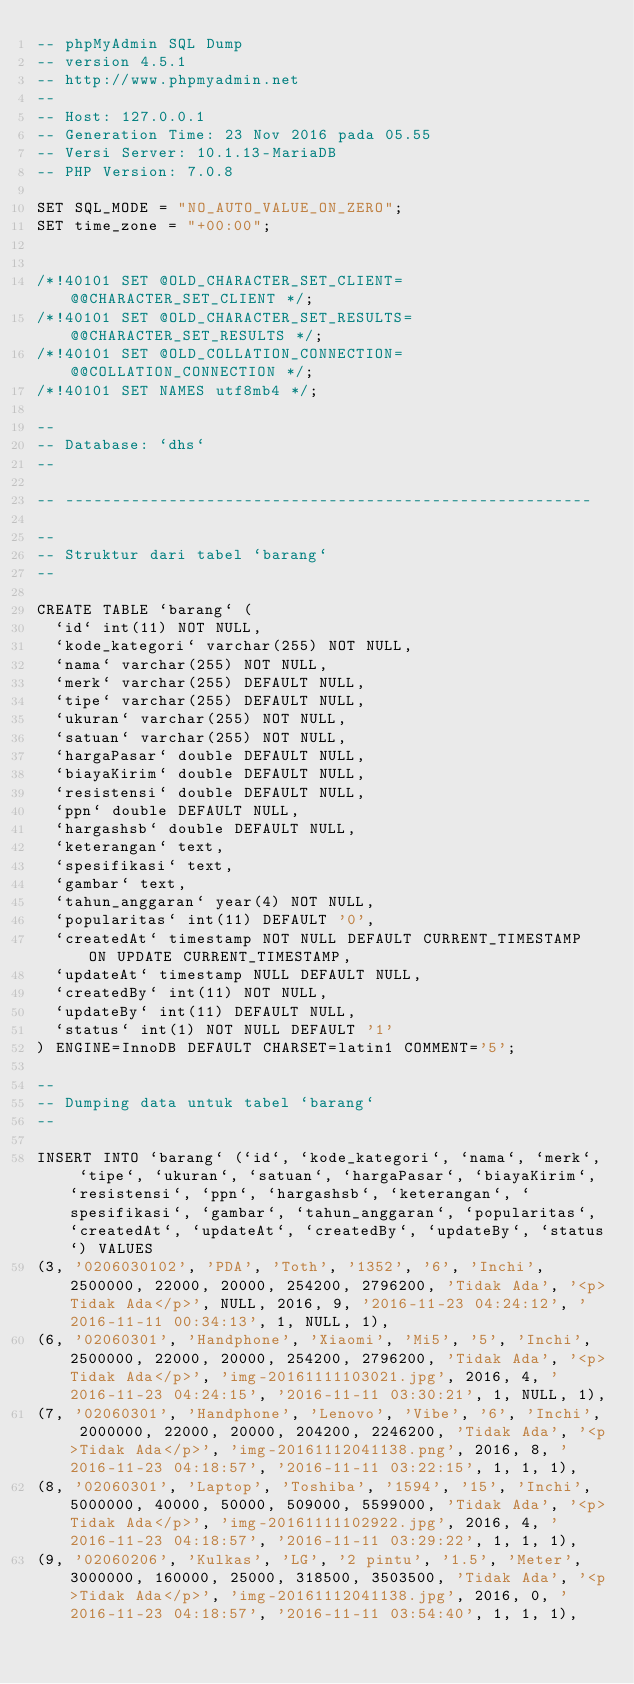<code> <loc_0><loc_0><loc_500><loc_500><_SQL_>-- phpMyAdmin SQL Dump
-- version 4.5.1
-- http://www.phpmyadmin.net
--
-- Host: 127.0.0.1
-- Generation Time: 23 Nov 2016 pada 05.55
-- Versi Server: 10.1.13-MariaDB
-- PHP Version: 7.0.8

SET SQL_MODE = "NO_AUTO_VALUE_ON_ZERO";
SET time_zone = "+00:00";


/*!40101 SET @OLD_CHARACTER_SET_CLIENT=@@CHARACTER_SET_CLIENT */;
/*!40101 SET @OLD_CHARACTER_SET_RESULTS=@@CHARACTER_SET_RESULTS */;
/*!40101 SET @OLD_COLLATION_CONNECTION=@@COLLATION_CONNECTION */;
/*!40101 SET NAMES utf8mb4 */;

--
-- Database: `dhs`
--

-- --------------------------------------------------------

--
-- Struktur dari tabel `barang`
--

CREATE TABLE `barang` (
  `id` int(11) NOT NULL,
  `kode_kategori` varchar(255) NOT NULL,
  `nama` varchar(255) NOT NULL,
  `merk` varchar(255) DEFAULT NULL,
  `tipe` varchar(255) DEFAULT NULL,
  `ukuran` varchar(255) NOT NULL,
  `satuan` varchar(255) NOT NULL,
  `hargaPasar` double DEFAULT NULL,
  `biayaKirim` double DEFAULT NULL,
  `resistensi` double DEFAULT NULL,
  `ppn` double DEFAULT NULL,
  `hargashsb` double DEFAULT NULL,
  `keterangan` text,
  `spesifikasi` text,
  `gambar` text,
  `tahun_anggaran` year(4) NOT NULL,
  `popularitas` int(11) DEFAULT '0',
  `createdAt` timestamp NOT NULL DEFAULT CURRENT_TIMESTAMP ON UPDATE CURRENT_TIMESTAMP,
  `updateAt` timestamp NULL DEFAULT NULL,
  `createdBy` int(11) NOT NULL,
  `updateBy` int(11) DEFAULT NULL,
  `status` int(1) NOT NULL DEFAULT '1'
) ENGINE=InnoDB DEFAULT CHARSET=latin1 COMMENT='5';

--
-- Dumping data untuk tabel `barang`
--

INSERT INTO `barang` (`id`, `kode_kategori`, `nama`, `merk`, `tipe`, `ukuran`, `satuan`, `hargaPasar`, `biayaKirim`, `resistensi`, `ppn`, `hargashsb`, `keterangan`, `spesifikasi`, `gambar`, `tahun_anggaran`, `popularitas`, `createdAt`, `updateAt`, `createdBy`, `updateBy`, `status`) VALUES
(3, '0206030102', 'PDA', 'Toth', '1352', '6', 'Inchi', 2500000, 22000, 20000, 254200, 2796200, 'Tidak Ada', '<p>Tidak Ada</p>', NULL, 2016, 9, '2016-11-23 04:24:12', '2016-11-11 00:34:13', 1, NULL, 1),
(6, '02060301', 'Handphone', 'Xiaomi', 'Mi5', '5', 'Inchi', 2500000, 22000, 20000, 254200, 2796200, 'Tidak Ada', '<p>Tidak Ada</p>', 'img-20161111103021.jpg', 2016, 4, '2016-11-23 04:24:15', '2016-11-11 03:30:21', 1, NULL, 1),
(7, '02060301', 'Handphone', 'Lenovo', 'Vibe', '6', 'Inchi', 2000000, 22000, 20000, 204200, 2246200, 'Tidak Ada', '<p>Tidak Ada</p>', 'img-20161112041138.png', 2016, 8, '2016-11-23 04:18:57', '2016-11-11 03:22:15', 1, 1, 1),
(8, '02060301', 'Laptop', 'Toshiba', '1594', '15', 'Inchi', 5000000, 40000, 50000, 509000, 5599000, 'Tidak Ada', '<p>Tidak Ada</p>', 'img-20161111102922.jpg', 2016, 4, '2016-11-23 04:18:57', '2016-11-11 03:29:22', 1, 1, 1),
(9, '02060206', 'Kulkas', 'LG', '2 pintu', '1.5', 'Meter', 3000000, 160000, 25000, 318500, 3503500, 'Tidak Ada', '<p>Tidak Ada</p>', 'img-20161112041138.jpg', 2016, 0, '2016-11-23 04:18:57', '2016-11-11 03:54:40', 1, 1, 1),</code> 